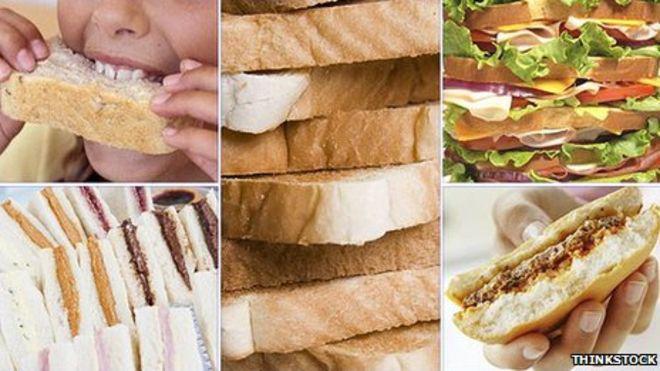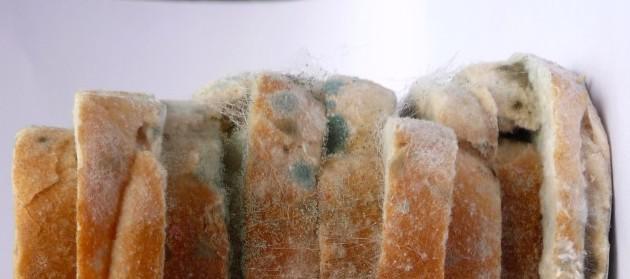The first image is the image on the left, the second image is the image on the right. Evaluate the accuracy of this statement regarding the images: "One image shows a bread loaf with at least one cut slice on a cutting board, and the other image includes multiple whole loaves with diagonal slash marks on top.". Is it true? Answer yes or no. No. The first image is the image on the left, the second image is the image on the right. Examine the images to the left and right. Is the description "In one image, two or more loaves of bread feature diagonal designs that were cut into the top of the dough prior to baking." accurate? Answer yes or no. No. 